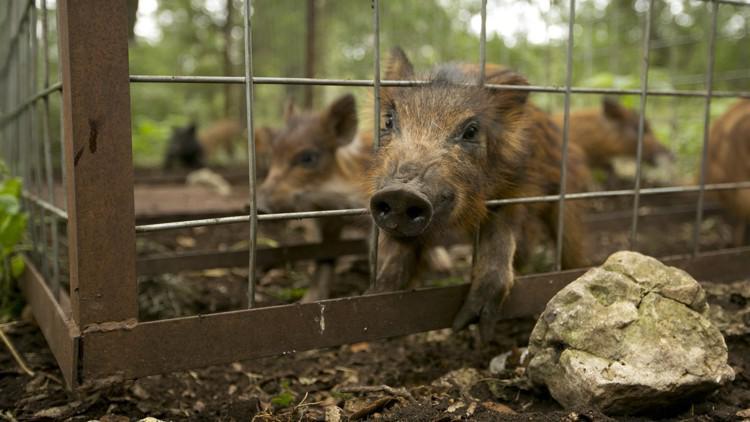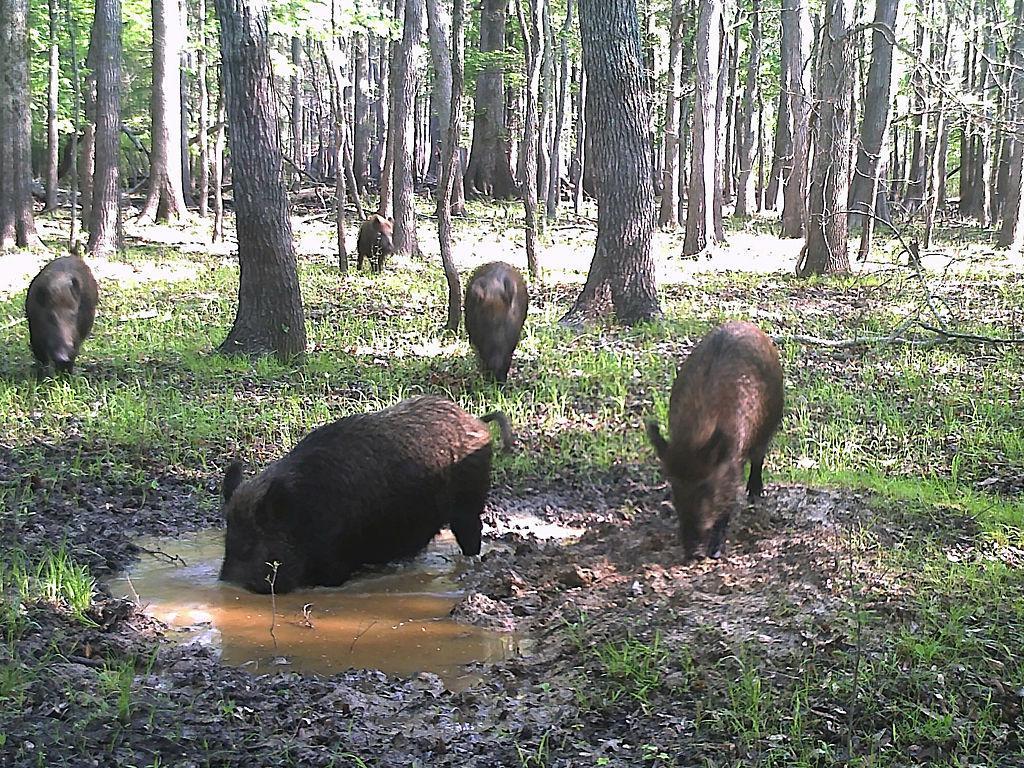The first image is the image on the left, the second image is the image on the right. Examine the images to the left and right. Is the description "An image shows at least one man in a camo hat crouched behind a dead hog lying on the ground with its mouth propped open." accurate? Answer yes or no. No. The first image is the image on the left, the second image is the image on the right. Assess this claim about the two images: "One image shows at least one hunter posing behind a warthog.". Correct or not? Answer yes or no. No. 